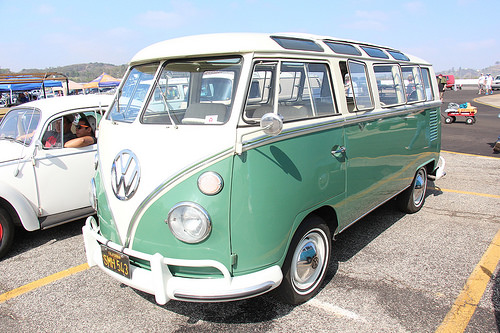<image>
Can you confirm if the bus is on the road? Yes. Looking at the image, I can see the bus is positioned on top of the road, with the road providing support. 